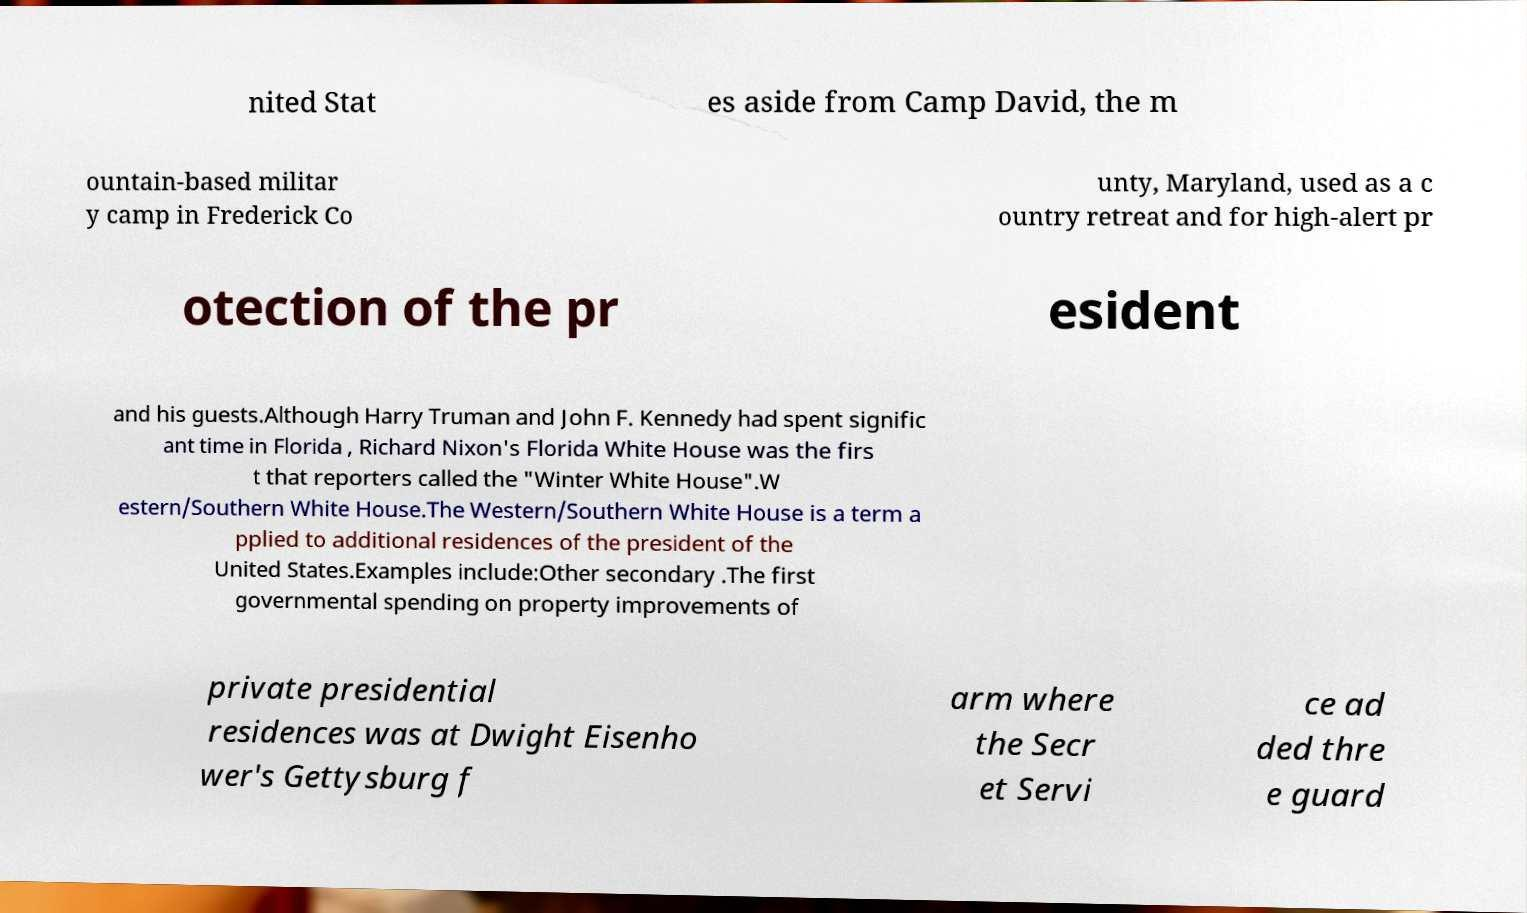Could you extract and type out the text from this image? nited Stat es aside from Camp David, the m ountain-based militar y camp in Frederick Co unty, Maryland, used as a c ountry retreat and for high-alert pr otection of the pr esident and his guests.Although Harry Truman and John F. Kennedy had spent signific ant time in Florida , Richard Nixon's Florida White House was the firs t that reporters called the "Winter White House".W estern/Southern White House.The Western/Southern White House is a term a pplied to additional residences of the president of the United States.Examples include:Other secondary .The first governmental spending on property improvements of private presidential residences was at Dwight Eisenho wer's Gettysburg f arm where the Secr et Servi ce ad ded thre e guard 